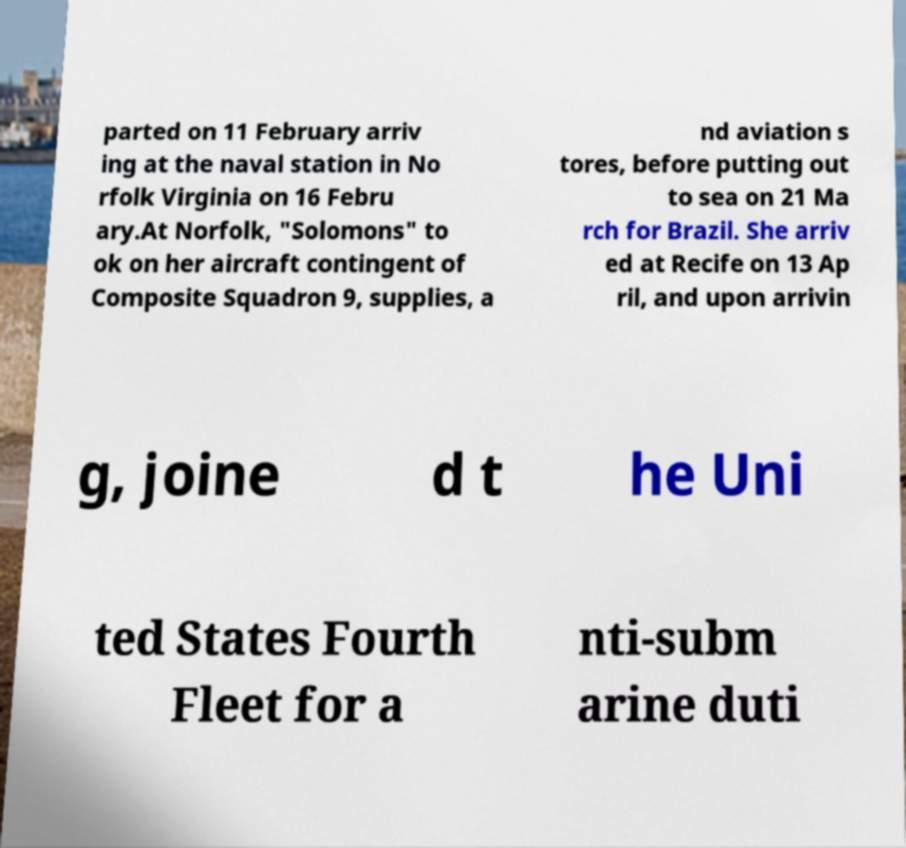Could you assist in decoding the text presented in this image and type it out clearly? parted on 11 February arriv ing at the naval station in No rfolk Virginia on 16 Febru ary.At Norfolk, "Solomons" to ok on her aircraft contingent of Composite Squadron 9, supplies, a nd aviation s tores, before putting out to sea on 21 Ma rch for Brazil. She arriv ed at Recife on 13 Ap ril, and upon arrivin g, joine d t he Uni ted States Fourth Fleet for a nti-subm arine duti 